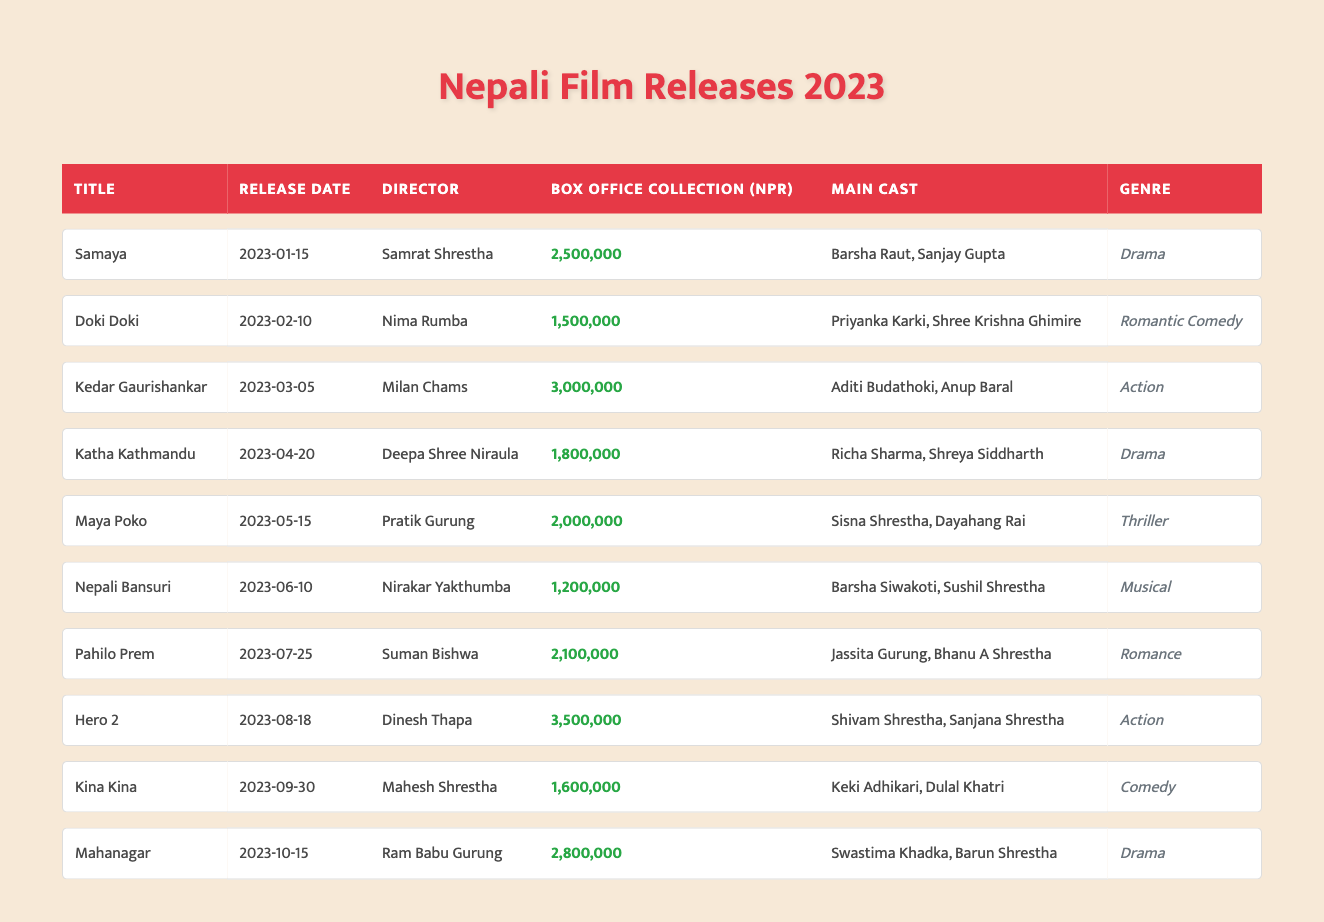What is the title of the movie with the highest box office collection? The movie with the highest box office collection can be found by scanning through the "Box Office Collection" column. The highest value is 3,500,000, which corresponds to the movie "Hero 2."
Answer: Hero 2 Which director has released a movie on April 20, 2023? By checking the "Release Date" column for the date April 20, 2023, we find the matching entry which lists "Deepa Shree Niraula" as the director of "Katha Kathmandu."
Answer: Deepa Shree Niraula What is the total box office collection of all the films released in 2023? We sum the box office collections of all the listed movies: 2500000 + 1500000 + 3000000 + 1800000 + 2000000 + 1200000 + 2100000 + 3500000 + 1600000 + 2800000 = 2,430,000 + 3000000 = 18,800,000.
Answer: 18,800,000 Is "Nepali Bansuri" a comedy film? According to the table, "Nepali Bansuri" is categorized under the "Musical" genre, so it is not a comedy film.
Answer: No What is the average box office collection for drama films released in 2023? The drama films in the table are "Samaya," "Katha Kathmandu," and "Mahanagar." Their box office collections are 2,500,000 + 1,800,000 + 2,800,000 = 7,100,000. There are 3 drama films, so the average is 7,100,000 / 3 = 2,366,666.66, which can be approximated to 2,366,667 when rounded.
Answer: 2,366,667 Which movie features "Barsha Raut" and who is the director? Looking through the "Main Cast" column, "Barsha Raut" appears in the movie "Samaya." The corresponding director for "Samaya" is "Samrat Shrestha."
Answer: Samrat Shrestha Was there a romantic comedy released before June 2023? The table shows a romantic comedy titled "Doki Doki" released on February 10, 2023. This satisfies the criteria of being a romantic comedy released before June 2023.
Answer: Yes How many action films were released in 2023, and what were their total collections? There are two action films: "Kedar Gaurishankar" with a collection of 3,000,000 and "Hero 2" with a collection of 3,500,000, summing to 3,000,000 + 3,500,000 = 6,500,000.
Answer: 2 action films; 6,500,000 